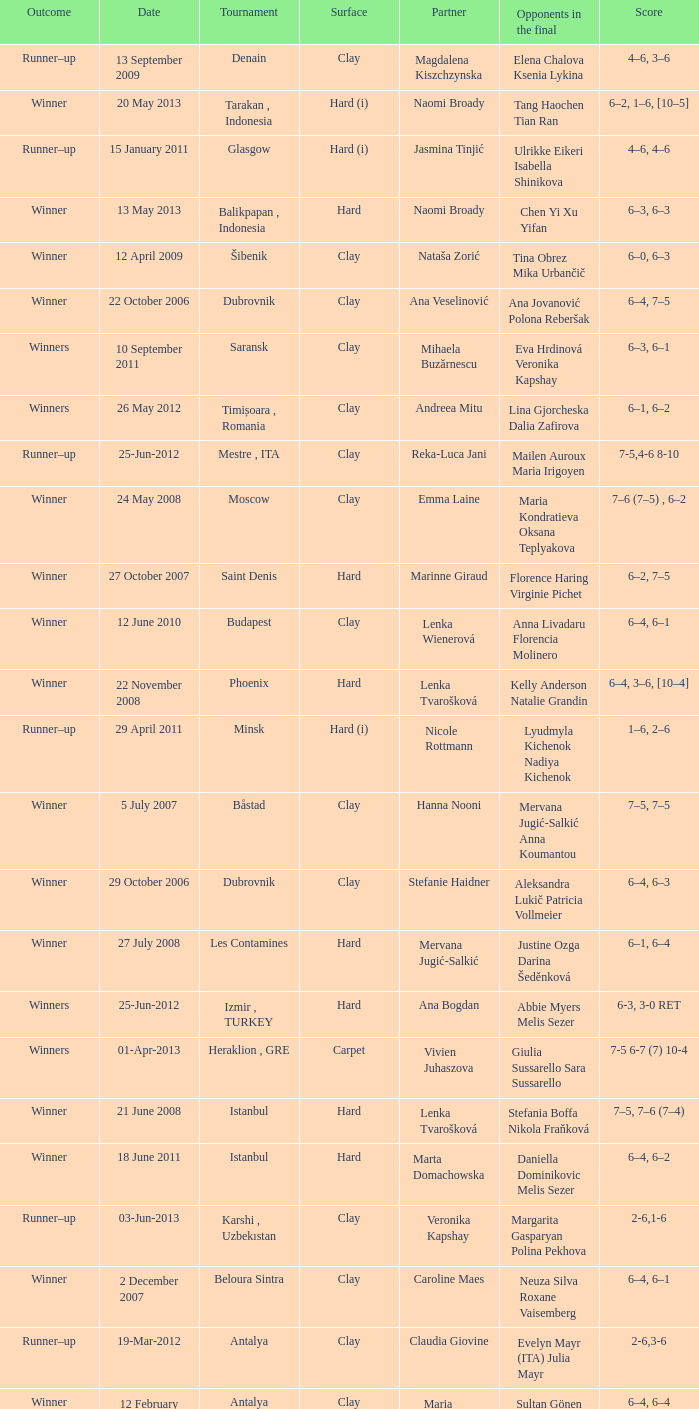Who were the opponents in the final at Noida? Kelly Anderson Chanelle Scheepers. 